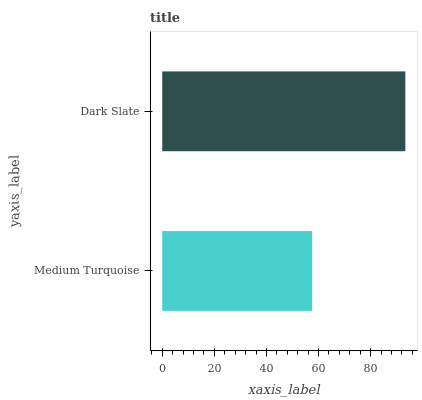Is Medium Turquoise the minimum?
Answer yes or no. Yes. Is Dark Slate the maximum?
Answer yes or no. Yes. Is Dark Slate the minimum?
Answer yes or no. No. Is Dark Slate greater than Medium Turquoise?
Answer yes or no. Yes. Is Medium Turquoise less than Dark Slate?
Answer yes or no. Yes. Is Medium Turquoise greater than Dark Slate?
Answer yes or no. No. Is Dark Slate less than Medium Turquoise?
Answer yes or no. No. Is Dark Slate the high median?
Answer yes or no. Yes. Is Medium Turquoise the low median?
Answer yes or no. Yes. Is Medium Turquoise the high median?
Answer yes or no. No. Is Dark Slate the low median?
Answer yes or no. No. 